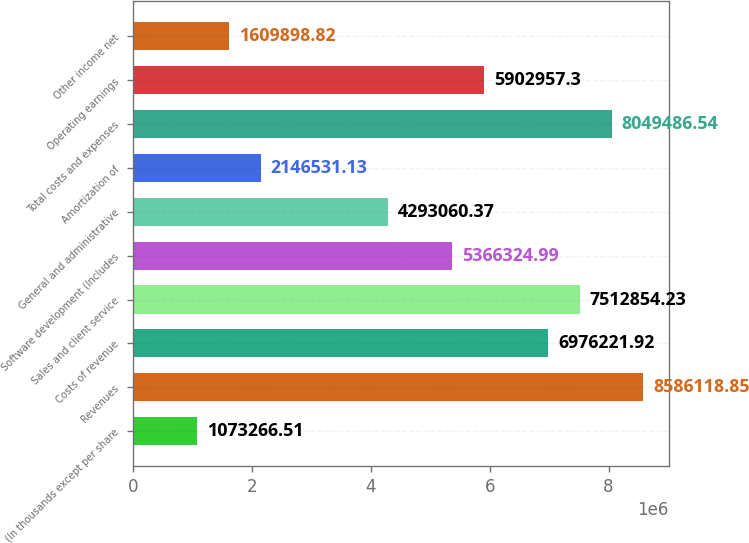Convert chart to OTSL. <chart><loc_0><loc_0><loc_500><loc_500><bar_chart><fcel>(In thousands except per share<fcel>Revenues<fcel>Costs of revenue<fcel>Sales and client service<fcel>Software development (Includes<fcel>General and administrative<fcel>Amortization of<fcel>Total costs and expenses<fcel>Operating earnings<fcel>Other income net<nl><fcel>1.07327e+06<fcel>8.58612e+06<fcel>6.97622e+06<fcel>7.51285e+06<fcel>5.36632e+06<fcel>4.29306e+06<fcel>2.14653e+06<fcel>8.04949e+06<fcel>5.90296e+06<fcel>1.6099e+06<nl></chart> 